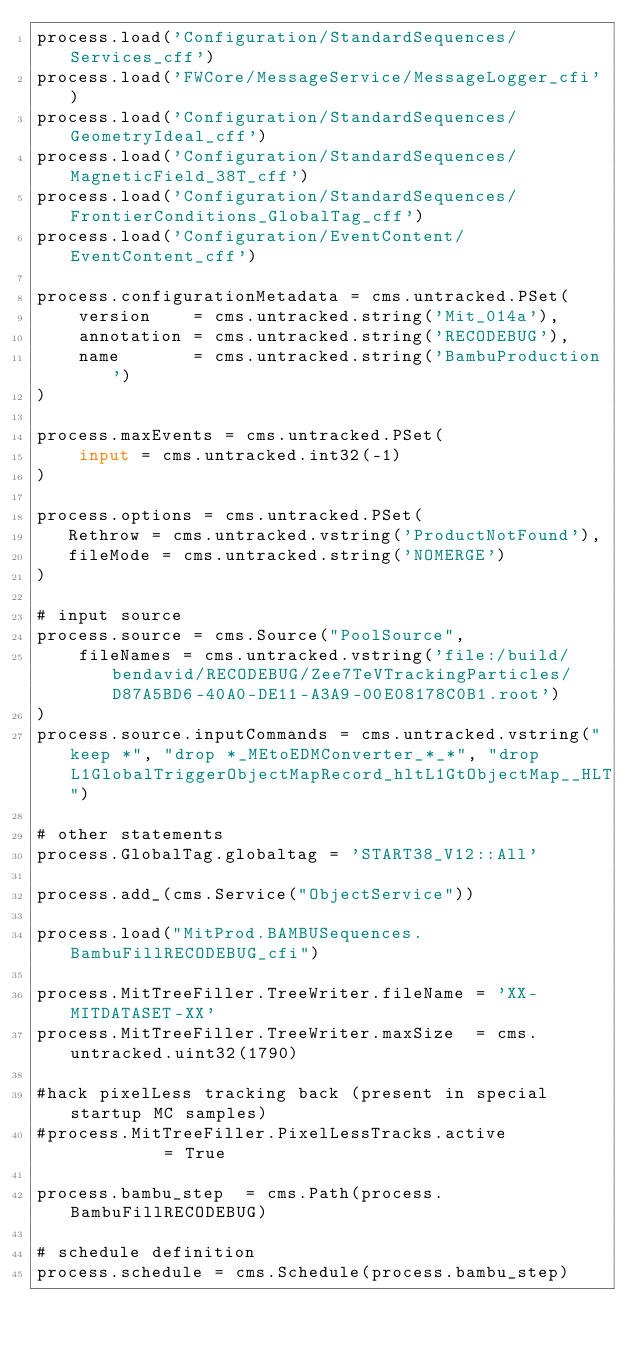Convert code to text. <code><loc_0><loc_0><loc_500><loc_500><_Python_>process.load('Configuration/StandardSequences/Services_cff')
process.load('FWCore/MessageService/MessageLogger_cfi')
process.load('Configuration/StandardSequences/GeometryIdeal_cff')
process.load('Configuration/StandardSequences/MagneticField_38T_cff')
process.load('Configuration/StandardSequences/FrontierConditions_GlobalTag_cff')
process.load('Configuration/EventContent/EventContent_cff')

process.configurationMetadata = cms.untracked.PSet(
    version    = cms.untracked.string('Mit_014a'),
    annotation = cms.untracked.string('RECODEBUG'),
    name       = cms.untracked.string('BambuProduction')
)

process.maxEvents = cms.untracked.PSet(
    input = cms.untracked.int32(-1)
)

process.options = cms.untracked.PSet(
   Rethrow = cms.untracked.vstring('ProductNotFound'),
   fileMode = cms.untracked.string('NOMERGE')
)

# input source
process.source = cms.Source("PoolSource",
    fileNames = cms.untracked.vstring('file:/build/bendavid/RECODEBUG/Zee7TeVTrackingParticles/D87A5BD6-40A0-DE11-A3A9-00E08178C0B1.root')
)
process.source.inputCommands = cms.untracked.vstring("keep *", "drop *_MEtoEDMConverter_*_*", "drop L1GlobalTriggerObjectMapRecord_hltL1GtObjectMap__HLT")

# other statements
process.GlobalTag.globaltag = 'START38_V12::All'

process.add_(cms.Service("ObjectService"))

process.load("MitProd.BAMBUSequences.BambuFillRECODEBUG_cfi")

process.MitTreeFiller.TreeWriter.fileName = 'XX-MITDATASET-XX'
process.MitTreeFiller.TreeWriter.maxSize  = cms.untracked.uint32(1790)

#hack pixelLess tracking back (present in special startup MC samples)
#process.MitTreeFiller.PixelLessTracks.active          = True
    
process.bambu_step  = cms.Path(process.BambuFillRECODEBUG)

# schedule definition
process.schedule = cms.Schedule(process.bambu_step)
</code> 